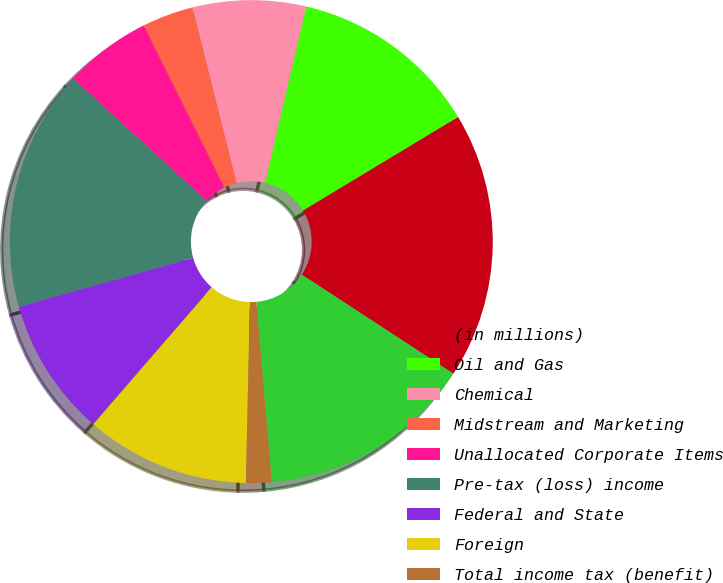Convert chart to OTSL. <chart><loc_0><loc_0><loc_500><loc_500><pie_chart><fcel>(in millions)<fcel>Oil and Gas<fcel>Chemical<fcel>Midstream and Marketing<fcel>Unallocated Corporate Items<fcel>Pre-tax (loss) income<fcel>Federal and State<fcel>Foreign<fcel>Total income tax (benefit)<fcel>Income (loss) from continuing<nl><fcel>17.85%<fcel>12.71%<fcel>7.57%<fcel>3.43%<fcel>5.86%<fcel>16.14%<fcel>9.29%<fcel>11.0%<fcel>1.72%<fcel>14.42%<nl></chart> 